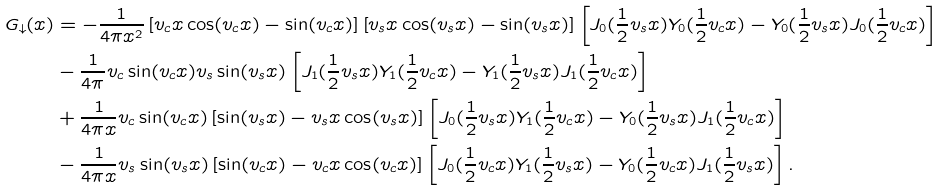<formula> <loc_0><loc_0><loc_500><loc_500>G _ { \downarrow } ( x ) & = - \frac { 1 } { 4 \pi x ^ { 2 } } \left [ v _ { c } x \cos ( v _ { c } x ) - \sin ( v _ { c } x ) \right ] \left [ v _ { s } x \cos ( v _ { s } x ) - \sin ( v _ { s } x ) \right ] \left [ J _ { 0 } ( \frac { 1 } { 2 } v _ { s } x ) Y _ { 0 } ( \frac { 1 } { 2 } v _ { c } x ) - Y _ { 0 } ( \frac { 1 } { 2 } v _ { s } x ) J _ { 0 } ( \frac { 1 } { 2 } v _ { c } x ) \right ] \\ & - \frac { 1 } { 4 \pi } v _ { c } \sin ( v _ { c } x ) v _ { s } \sin ( v _ { s } x ) \left [ J _ { 1 } ( \frac { 1 } { 2 } v _ { s } x ) Y _ { 1 } ( \frac { 1 } { 2 } v _ { c } x ) - Y _ { 1 } ( \frac { 1 } { 2 } v _ { s } x ) J _ { 1 } ( \frac { 1 } { 2 } v _ { c } x ) \right ] \\ & + \frac { 1 } { 4 \pi x } v _ { c } \sin ( v _ { c } x ) \left [ \sin ( v _ { s } x ) - v _ { s } x \cos ( v _ { s } x ) \right ] \left [ J _ { 0 } ( \frac { 1 } { 2 } v _ { s } x ) Y _ { 1 } ( \frac { 1 } { 2 } v _ { c } x ) - Y _ { 0 } ( \frac { 1 } { 2 } v _ { s } x ) J _ { 1 } ( \frac { 1 } { 2 } v _ { c } x ) \right ] \\ & - \frac { 1 } { 4 \pi x } v _ { s } \sin ( v _ { s } x ) \left [ \sin ( v _ { c } x ) - v _ { c } x \cos ( v _ { c } x ) \right ] \left [ J _ { 0 } ( \frac { 1 } { 2 } v _ { c } x ) Y _ { 1 } ( \frac { 1 } { 2 } v _ { s } x ) - Y _ { 0 } ( \frac { 1 } { 2 } v _ { c } x ) J _ { 1 } ( \frac { 1 } { 2 } v _ { s } x ) \right ] .</formula> 